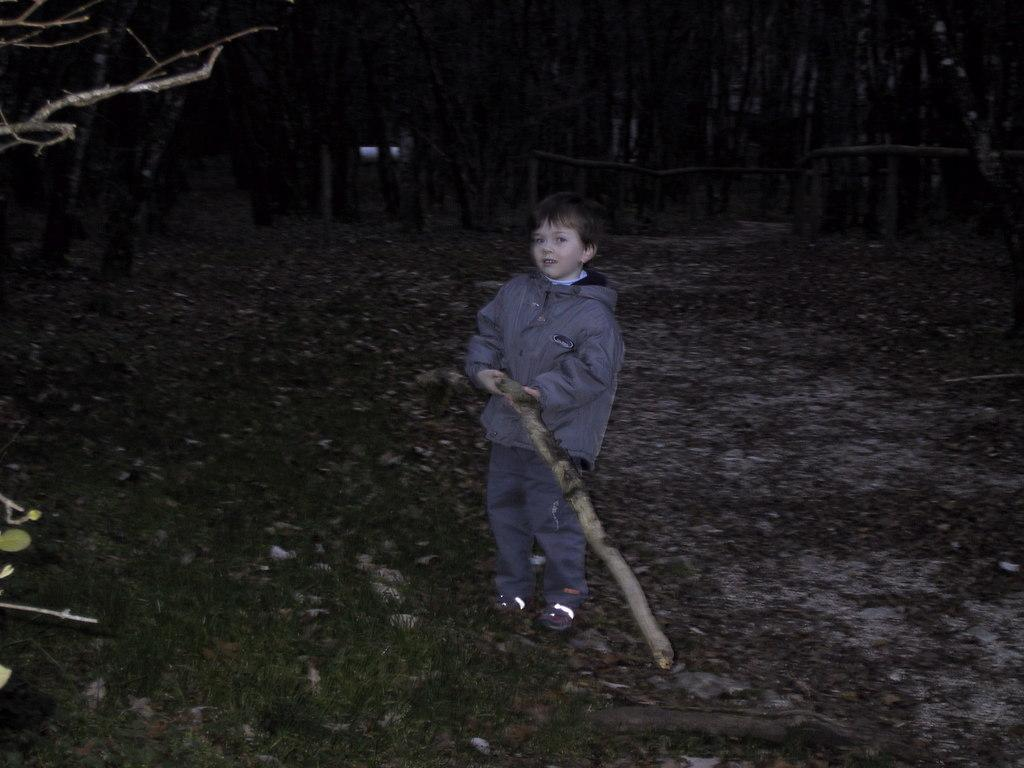Who is the main subject in the image? There is a boy in the image. What is the boy doing in the image? The boy is standing in the image. What object is the boy holding in the image? The boy is holding a wooden staff in the image. What type of terrain is visible in the image? There is grass in the image. What can be seen in the background of the image? There are trees in the background of the image. Where is the maid in the image? There is no maid present in the image. Can you see a nest in the trees in the background of the image? There is no nest visible in the trees in the background of the image. 